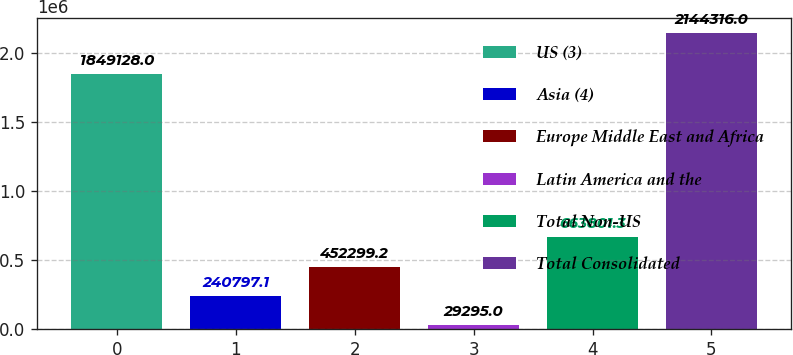Convert chart. <chart><loc_0><loc_0><loc_500><loc_500><bar_chart><fcel>US (3)<fcel>Asia (4)<fcel>Europe Middle East and Africa<fcel>Latin America and the<fcel>Total Non-US<fcel>Total Consolidated<nl><fcel>1.84913e+06<fcel>240797<fcel>452299<fcel>29295<fcel>663801<fcel>2.14432e+06<nl></chart> 